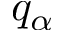<formula> <loc_0><loc_0><loc_500><loc_500>q _ { \alpha }</formula> 